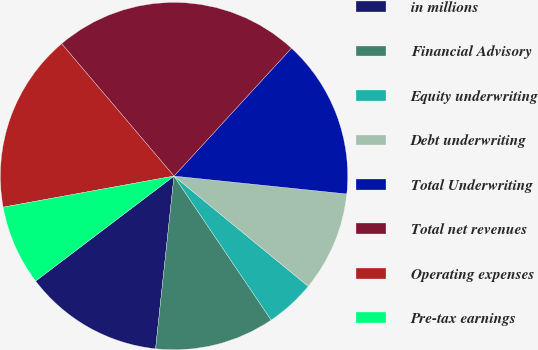<chart> <loc_0><loc_0><loc_500><loc_500><pie_chart><fcel>in millions<fcel>Financial Advisory<fcel>Equity underwriting<fcel>Debt underwriting<fcel>Total Underwriting<fcel>Total net revenues<fcel>Operating expenses<fcel>Pre-tax earnings<nl><fcel>12.98%<fcel>11.14%<fcel>4.61%<fcel>9.3%<fcel>14.82%<fcel>23.02%<fcel>16.66%<fcel>7.46%<nl></chart> 